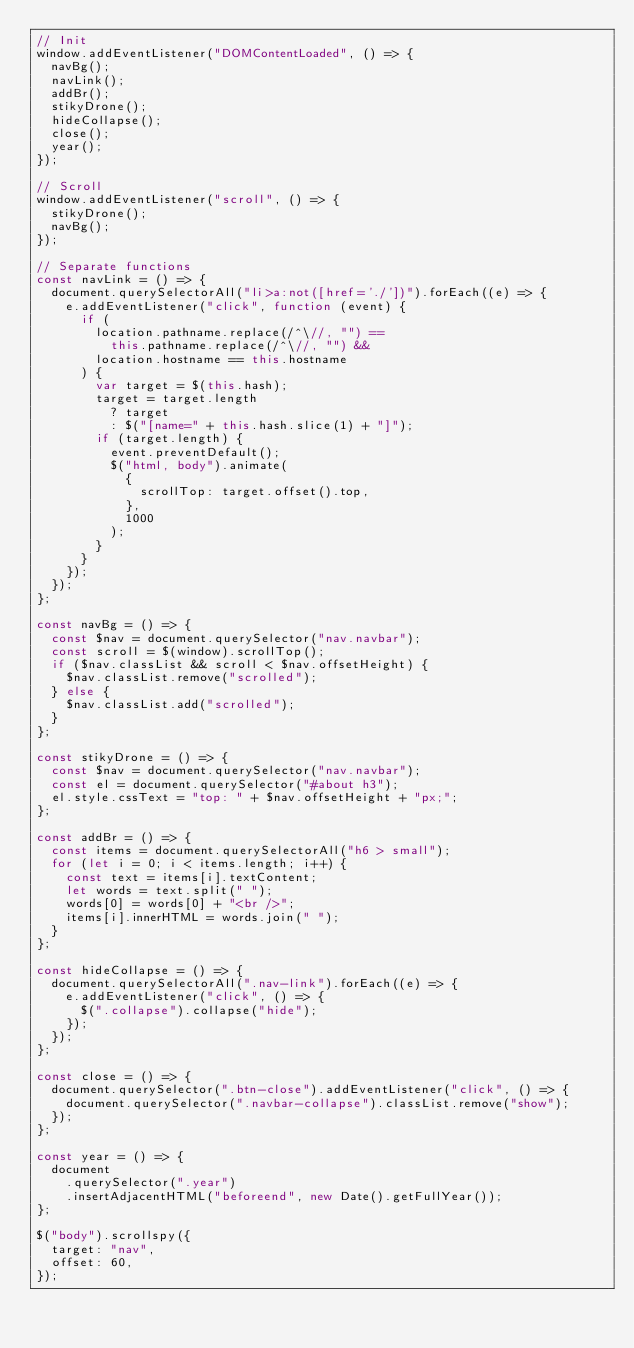<code> <loc_0><loc_0><loc_500><loc_500><_JavaScript_>// Init
window.addEventListener("DOMContentLoaded", () => {
  navBg();
  navLink();
  addBr();
  stikyDrone();
  hideCollapse();
  close();
  year();
});

// Scroll
window.addEventListener("scroll", () => {
  stikyDrone();
  navBg();
});

// Separate functions
const navLink = () => {
  document.querySelectorAll("li>a:not([href='./'])").forEach((e) => {
    e.addEventListener("click", function (event) {
      if (
        location.pathname.replace(/^\//, "") ==
          this.pathname.replace(/^\//, "") &&
        location.hostname == this.hostname
      ) {
        var target = $(this.hash);
        target = target.length
          ? target
          : $("[name=" + this.hash.slice(1) + "]");
        if (target.length) {
          event.preventDefault();
          $("html, body").animate(
            {
              scrollTop: target.offset().top,
            },
            1000
          );
        }
      }
    });
  });
};

const navBg = () => {
  const $nav = document.querySelector("nav.navbar");
  const scroll = $(window).scrollTop();
  if ($nav.classList && scroll < $nav.offsetHeight) {
    $nav.classList.remove("scrolled");
  } else {
    $nav.classList.add("scrolled");
  }
};

const stikyDrone = () => {
  const $nav = document.querySelector("nav.navbar");
  const el = document.querySelector("#about h3");
  el.style.cssText = "top: " + $nav.offsetHeight + "px;";
};

const addBr = () => {
  const items = document.querySelectorAll("h6 > small");
  for (let i = 0; i < items.length; i++) {
    const text = items[i].textContent;
    let words = text.split(" ");
    words[0] = words[0] + "<br />";
    items[i].innerHTML = words.join(" ");
  }
};

const hideCollapse = () => {
  document.querySelectorAll(".nav-link").forEach((e) => {
    e.addEventListener("click", () => {
      $(".collapse").collapse("hide");
    });
  });
};

const close = () => {
  document.querySelector(".btn-close").addEventListener("click", () => {
    document.querySelector(".navbar-collapse").classList.remove("show");
  });
};

const year = () => {
  document
    .querySelector(".year")
    .insertAdjacentHTML("beforeend", new Date().getFullYear());
};

$("body").scrollspy({
  target: "nav",
  offset: 60,
});
</code> 